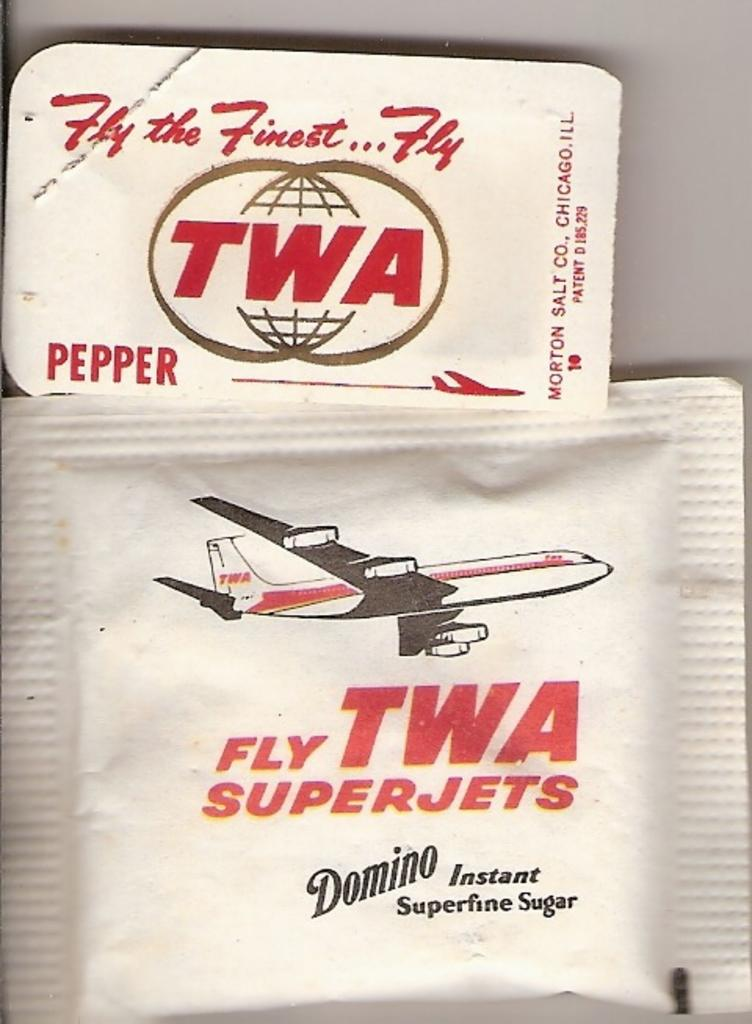<image>
Share a concise interpretation of the image provided. Packets of sugar and pepper with an old TWA logo on them. 